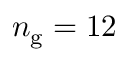<formula> <loc_0><loc_0><loc_500><loc_500>n _ { g } = 1 2</formula> 